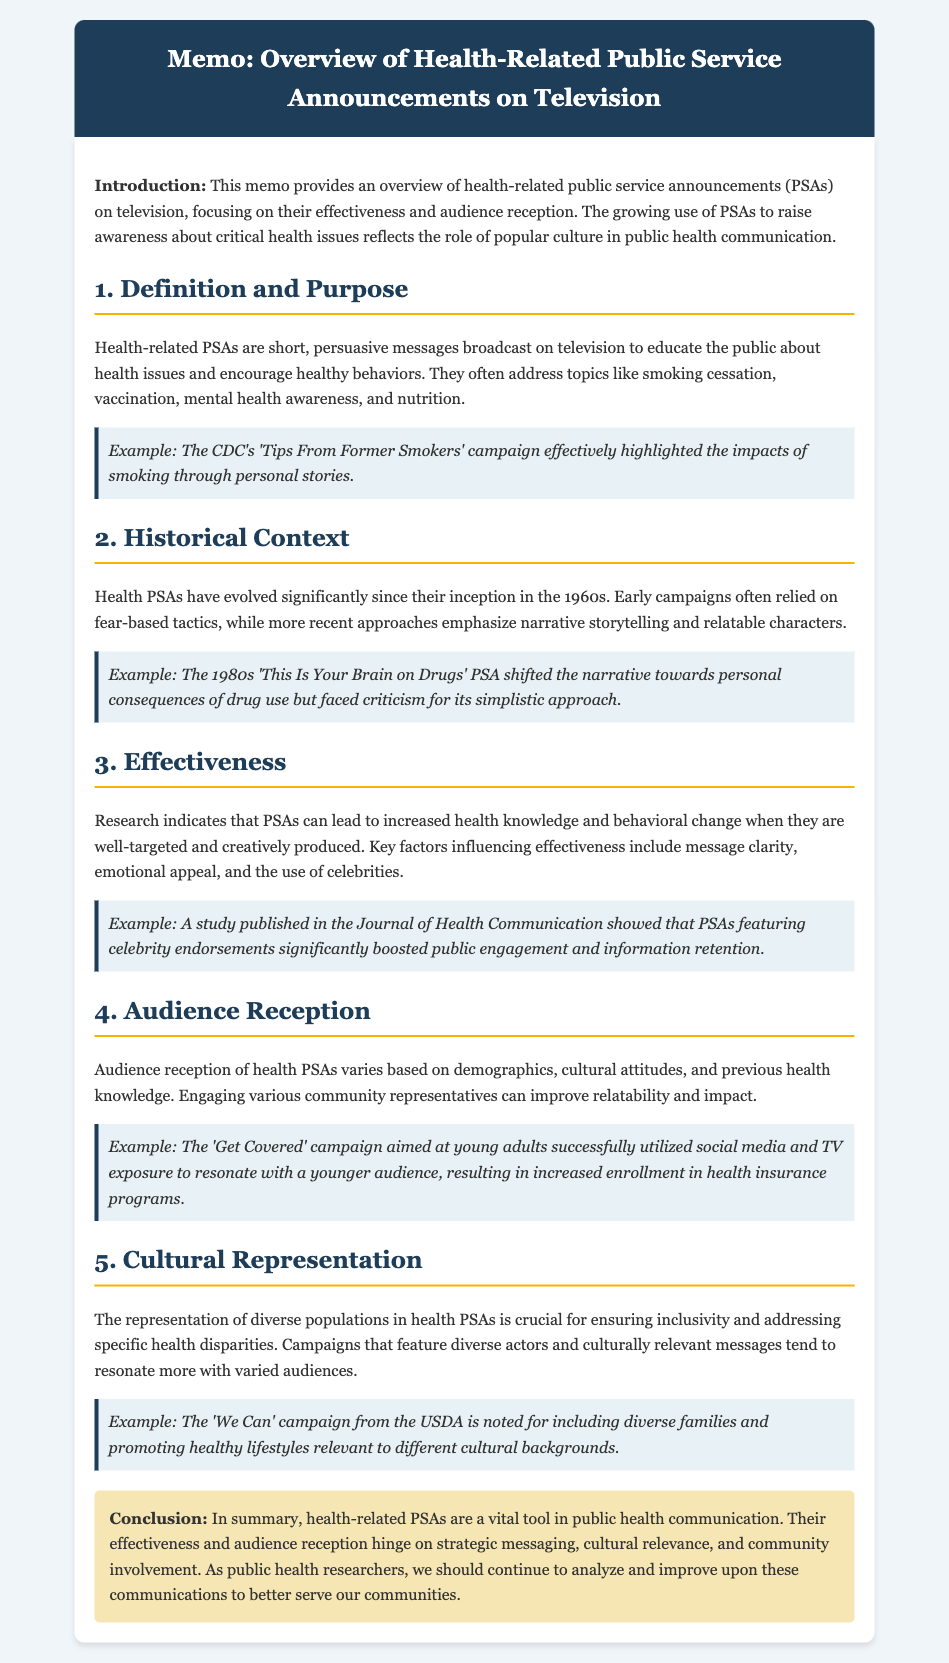What are health-related PSAs? Health-related PSAs are short, persuasive messages broadcast on television to educate the public about health issues and encourage healthy behaviors.
Answer: Short, persuasive messages What decade did health PSAs begin? The memo states that health PSAs have evolved significantly since their inception in the 1960s.
Answer: 1960s Which campaign highlighted smoking impacts? The example provided in the memo refers to the CDC's 'Tips From Former Smokers' campaign.
Answer: CDC's 'Tips From Former Smokers' What key factors influence PSA effectiveness? The memo mentions message clarity, emotional appeal, and the use of celebrities as key factors influencing effectiveness.
Answer: Message clarity, emotional appeal, and celebrity use What was one criticism of the 1980s drug PSA? The 'This Is Your Brain on Drugs' PSA faced criticism for its simplistic approach.
Answer: Simplistic approach Which campaign was aimed at young adults? The 'Get Covered' campaign successfully utilized social media and TV exposure to resonate with a younger audience.
Answer: Get Covered What campaign is noted for its cultural diversity? The 'We Can' campaign from the USDA is noted for including diverse families and promoting healthy lifestyles relevant to different cultural backgrounds.
Answer: We Can How can audience reception of PSAs vary? Audience reception varies based on demographics, cultural attitudes, and previous health knowledge.
Answer: Demographics, cultural attitudes, and previous health knowledge What role do health PSAs play in public health communication? Health PSAs are a vital tool in public health communication according to the memo's conclusion.
Answer: Vital tool 